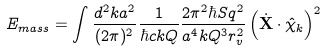<formula> <loc_0><loc_0><loc_500><loc_500>E _ { m a s s } = \int \frac { d ^ { 2 } k a ^ { 2 } } { ( 2 \pi ) ^ { 2 } } \frac { 1 } { \hbar { c } k Q } \frac { 2 \pi ^ { 2 } \hbar { S } q ^ { 2 } } { a ^ { 4 } k Q ^ { 3 } r _ { v } ^ { 2 } } \left ( \dot { \mathbf X } \cdot \hat { \mathbf \chi } _ { k } \right ) ^ { 2 }</formula> 